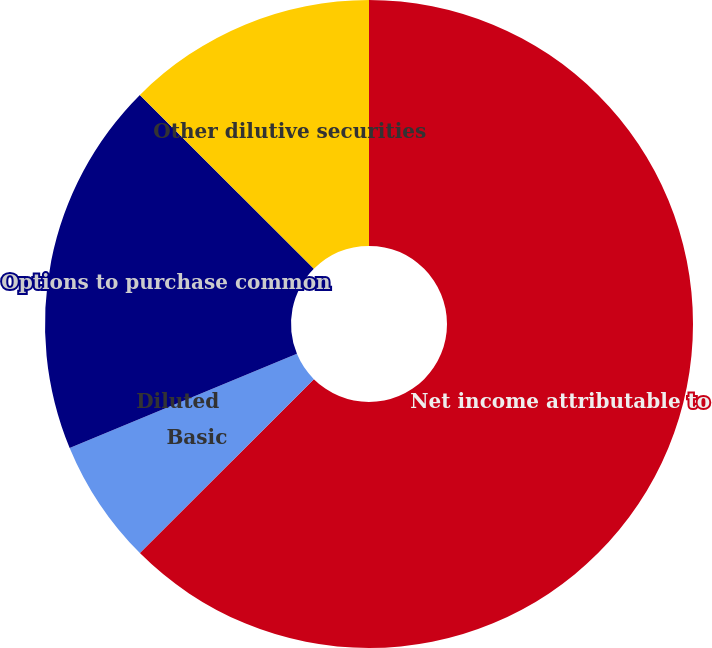Convert chart. <chart><loc_0><loc_0><loc_500><loc_500><pie_chart><fcel>Net income attributable to<fcel>Basic<fcel>Diluted<fcel>Options to purchase common<fcel>Other dilutive securities<nl><fcel>62.5%<fcel>6.25%<fcel>0.0%<fcel>18.75%<fcel>12.5%<nl></chart> 